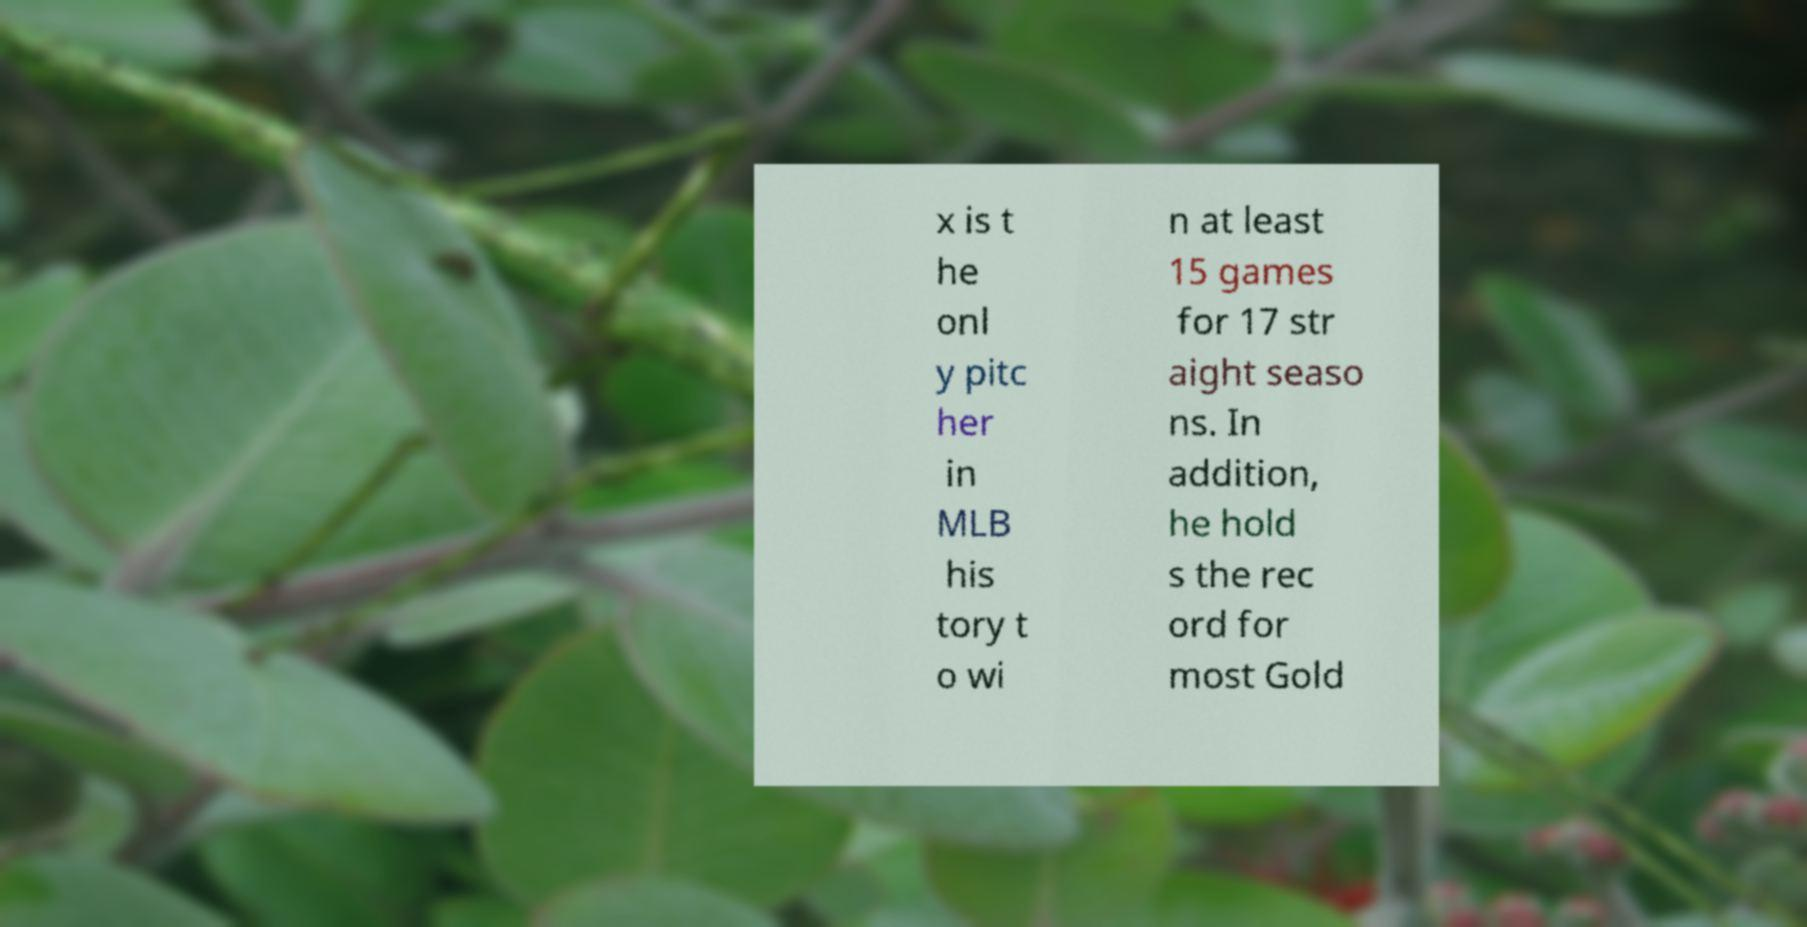Can you accurately transcribe the text from the provided image for me? x is t he onl y pitc her in MLB his tory t o wi n at least 15 games for 17 str aight seaso ns. In addition, he hold s the rec ord for most Gold 